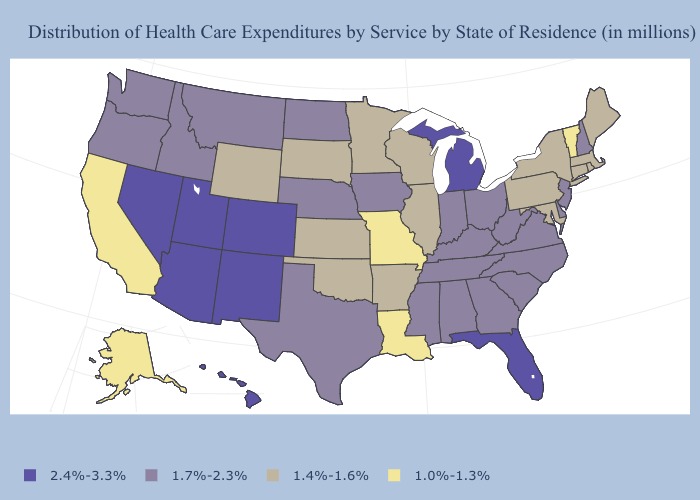Name the states that have a value in the range 1.4%-1.6%?
Concise answer only. Arkansas, Connecticut, Illinois, Kansas, Maine, Maryland, Massachusetts, Minnesota, New York, Oklahoma, Pennsylvania, Rhode Island, South Dakota, Wisconsin, Wyoming. Does California have the highest value in the West?
Be succinct. No. What is the value of Indiana?
Write a very short answer. 1.7%-2.3%. What is the value of Nebraska?
Be succinct. 1.7%-2.3%. What is the value of Georgia?
Write a very short answer. 1.7%-2.3%. Is the legend a continuous bar?
Quick response, please. No. Name the states that have a value in the range 1.4%-1.6%?
Quick response, please. Arkansas, Connecticut, Illinois, Kansas, Maine, Maryland, Massachusetts, Minnesota, New York, Oklahoma, Pennsylvania, Rhode Island, South Dakota, Wisconsin, Wyoming. Is the legend a continuous bar?
Keep it brief. No. Which states have the highest value in the USA?
Concise answer only. Arizona, Colorado, Florida, Hawaii, Michigan, Nevada, New Mexico, Utah. Among the states that border Minnesota , which have the highest value?
Concise answer only. Iowa, North Dakota. What is the value of Maine?
Write a very short answer. 1.4%-1.6%. Is the legend a continuous bar?
Write a very short answer. No. Does the first symbol in the legend represent the smallest category?
Quick response, please. No. Among the states that border Kentucky , does Illinois have the highest value?
Short answer required. No. How many symbols are there in the legend?
Write a very short answer. 4. 